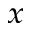Convert formula to latex. <formula><loc_0><loc_0><loc_500><loc_500>_ { x }</formula> 